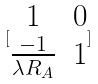<formula> <loc_0><loc_0><loc_500><loc_500>[ \begin{matrix} 1 & 0 \\ \frac { - 1 } { \lambda R _ { A } } & 1 \end{matrix} ]</formula> 